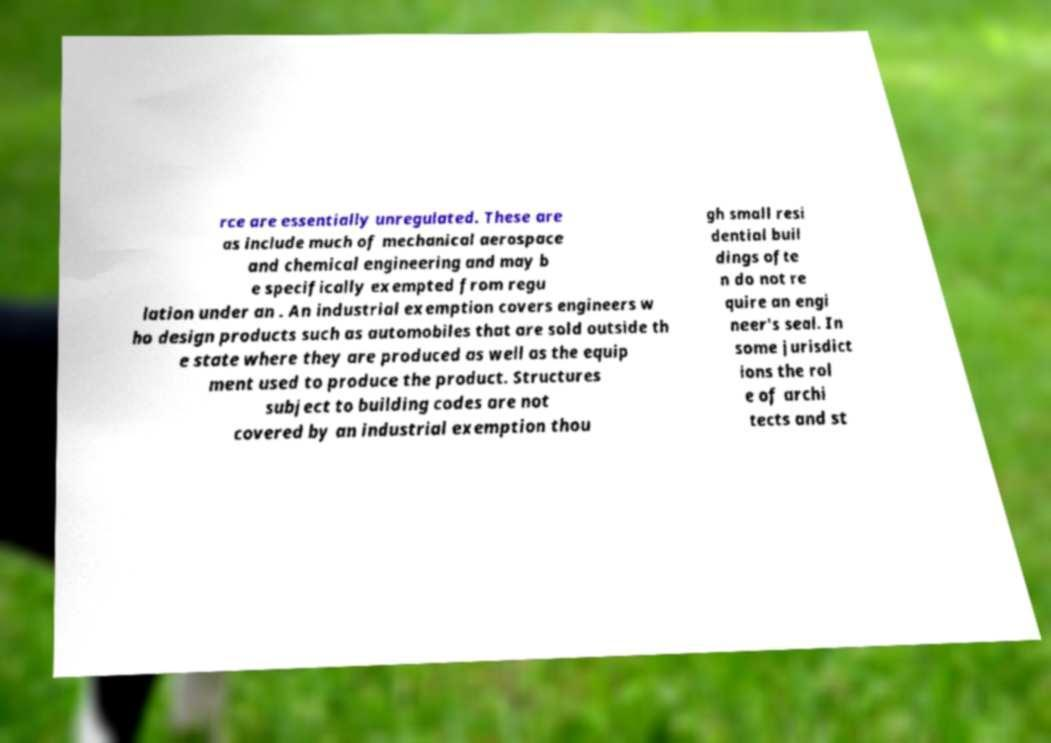Could you assist in decoding the text presented in this image and type it out clearly? rce are essentially unregulated. These are as include much of mechanical aerospace and chemical engineering and may b e specifically exempted from regu lation under an . An industrial exemption covers engineers w ho design products such as automobiles that are sold outside th e state where they are produced as well as the equip ment used to produce the product. Structures subject to building codes are not covered by an industrial exemption thou gh small resi dential buil dings ofte n do not re quire an engi neer's seal. In some jurisdict ions the rol e of archi tects and st 